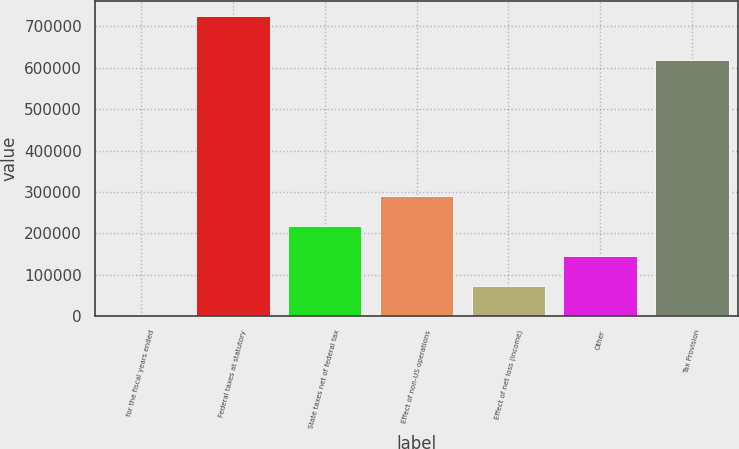<chart> <loc_0><loc_0><loc_500><loc_500><bar_chart><fcel>for the fiscal years ended<fcel>Federal taxes at statutory<fcel>State taxes net of federal tax<fcel>Effect of non-US operations<fcel>Effect of net loss (income)<fcel>Other<fcel>Tax Provision<nl><fcel>2010<fcel>724433<fcel>218737<fcel>290979<fcel>74252.3<fcel>146495<fcel>618312<nl></chart> 